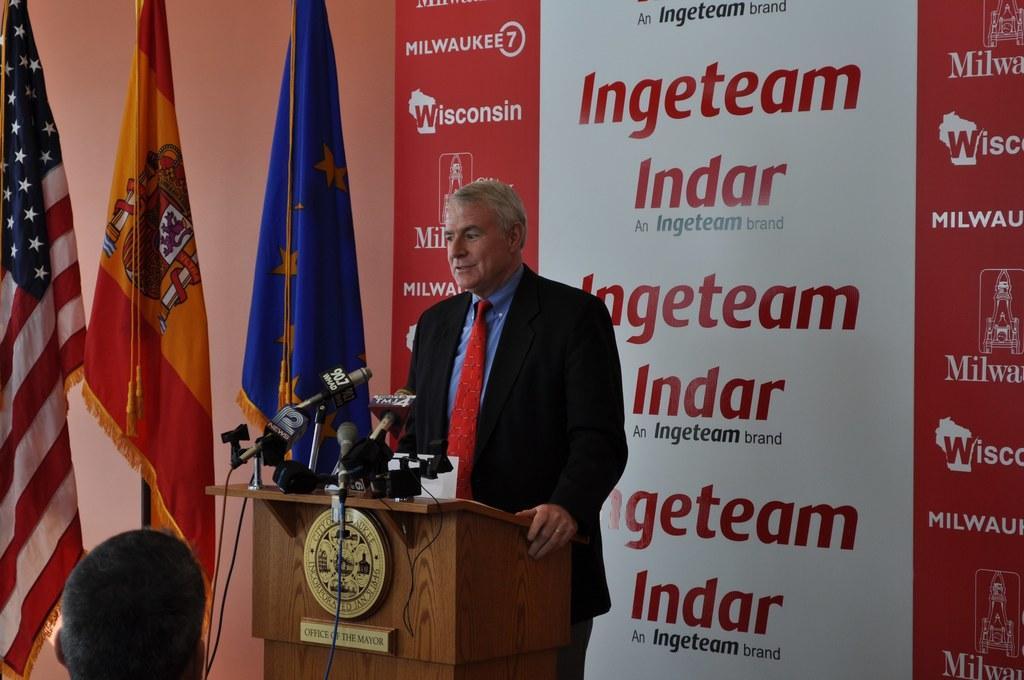Can you describe this image briefly? On the left we can see flags, podium, mics, cables and a person's head. In the middle there is a person standing. Towards right there is a banner. 